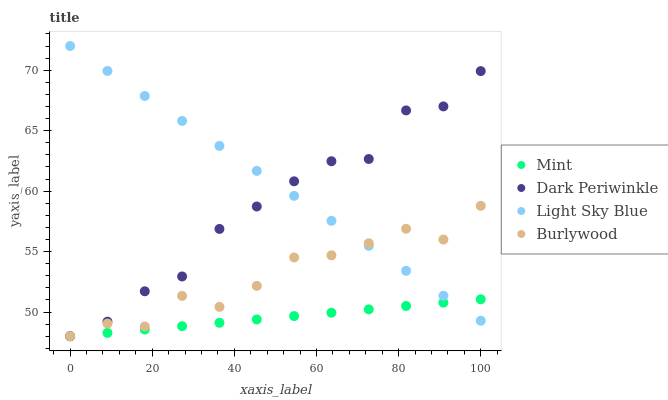Does Mint have the minimum area under the curve?
Answer yes or no. Yes. Does Light Sky Blue have the maximum area under the curve?
Answer yes or no. Yes. Does Light Sky Blue have the minimum area under the curve?
Answer yes or no. No. Does Mint have the maximum area under the curve?
Answer yes or no. No. Is Mint the smoothest?
Answer yes or no. Yes. Is Burlywood the roughest?
Answer yes or no. Yes. Is Light Sky Blue the smoothest?
Answer yes or no. No. Is Light Sky Blue the roughest?
Answer yes or no. No. Does Burlywood have the lowest value?
Answer yes or no. Yes. Does Light Sky Blue have the lowest value?
Answer yes or no. No. Does Light Sky Blue have the highest value?
Answer yes or no. Yes. Does Mint have the highest value?
Answer yes or no. No. Does Light Sky Blue intersect Mint?
Answer yes or no. Yes. Is Light Sky Blue less than Mint?
Answer yes or no. No. Is Light Sky Blue greater than Mint?
Answer yes or no. No. 